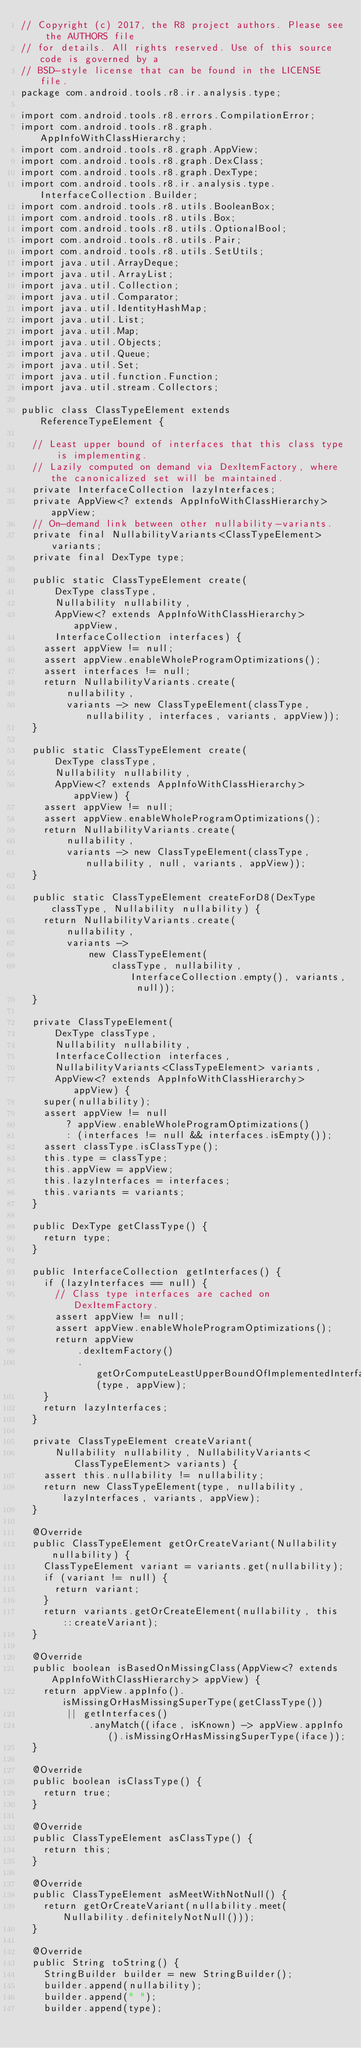<code> <loc_0><loc_0><loc_500><loc_500><_Java_>// Copyright (c) 2017, the R8 project authors. Please see the AUTHORS file
// for details. All rights reserved. Use of this source code is governed by a
// BSD-style license that can be found in the LICENSE file.
package com.android.tools.r8.ir.analysis.type;

import com.android.tools.r8.errors.CompilationError;
import com.android.tools.r8.graph.AppInfoWithClassHierarchy;
import com.android.tools.r8.graph.AppView;
import com.android.tools.r8.graph.DexClass;
import com.android.tools.r8.graph.DexType;
import com.android.tools.r8.ir.analysis.type.InterfaceCollection.Builder;
import com.android.tools.r8.utils.BooleanBox;
import com.android.tools.r8.utils.Box;
import com.android.tools.r8.utils.OptionalBool;
import com.android.tools.r8.utils.Pair;
import com.android.tools.r8.utils.SetUtils;
import java.util.ArrayDeque;
import java.util.ArrayList;
import java.util.Collection;
import java.util.Comparator;
import java.util.IdentityHashMap;
import java.util.List;
import java.util.Map;
import java.util.Objects;
import java.util.Queue;
import java.util.Set;
import java.util.function.Function;
import java.util.stream.Collectors;

public class ClassTypeElement extends ReferenceTypeElement {

  // Least upper bound of interfaces that this class type is implementing.
  // Lazily computed on demand via DexItemFactory, where the canonicalized set will be maintained.
  private InterfaceCollection lazyInterfaces;
  private AppView<? extends AppInfoWithClassHierarchy> appView;
  // On-demand link between other nullability-variants.
  private final NullabilityVariants<ClassTypeElement> variants;
  private final DexType type;

  public static ClassTypeElement create(
      DexType classType,
      Nullability nullability,
      AppView<? extends AppInfoWithClassHierarchy> appView,
      InterfaceCollection interfaces) {
    assert appView != null;
    assert appView.enableWholeProgramOptimizations();
    assert interfaces != null;
    return NullabilityVariants.create(
        nullability,
        variants -> new ClassTypeElement(classType, nullability, interfaces, variants, appView));
  }

  public static ClassTypeElement create(
      DexType classType,
      Nullability nullability,
      AppView<? extends AppInfoWithClassHierarchy> appView) {
    assert appView != null;
    assert appView.enableWholeProgramOptimizations();
    return NullabilityVariants.create(
        nullability,
        variants -> new ClassTypeElement(classType, nullability, null, variants, appView));
  }

  public static ClassTypeElement createForD8(DexType classType, Nullability nullability) {
    return NullabilityVariants.create(
        nullability,
        variants ->
            new ClassTypeElement(
                classType, nullability, InterfaceCollection.empty(), variants, null));
  }

  private ClassTypeElement(
      DexType classType,
      Nullability nullability,
      InterfaceCollection interfaces,
      NullabilityVariants<ClassTypeElement> variants,
      AppView<? extends AppInfoWithClassHierarchy> appView) {
    super(nullability);
    assert appView != null
        ? appView.enableWholeProgramOptimizations()
        : (interfaces != null && interfaces.isEmpty());
    assert classType.isClassType();
    this.type = classType;
    this.appView = appView;
    this.lazyInterfaces = interfaces;
    this.variants = variants;
  }

  public DexType getClassType() {
    return type;
  }

  public InterfaceCollection getInterfaces() {
    if (lazyInterfaces == null) {
      // Class type interfaces are cached on DexItemFactory.
      assert appView != null;
      assert appView.enableWholeProgramOptimizations();
      return appView
          .dexItemFactory()
          .getOrComputeLeastUpperBoundOfImplementedInterfaces(type, appView);
    }
    return lazyInterfaces;
  }

  private ClassTypeElement createVariant(
      Nullability nullability, NullabilityVariants<ClassTypeElement> variants) {
    assert this.nullability != nullability;
    return new ClassTypeElement(type, nullability, lazyInterfaces, variants, appView);
  }

  @Override
  public ClassTypeElement getOrCreateVariant(Nullability nullability) {
    ClassTypeElement variant = variants.get(nullability);
    if (variant != null) {
      return variant;
    }
    return variants.getOrCreateElement(nullability, this::createVariant);
  }

  @Override
  public boolean isBasedOnMissingClass(AppView<? extends AppInfoWithClassHierarchy> appView) {
    return appView.appInfo().isMissingOrHasMissingSuperType(getClassType())
        || getInterfaces()
            .anyMatch((iface, isKnown) -> appView.appInfo().isMissingOrHasMissingSuperType(iface));
  }

  @Override
  public boolean isClassType() {
    return true;
  }

  @Override
  public ClassTypeElement asClassType() {
    return this;
  }

  @Override
  public ClassTypeElement asMeetWithNotNull() {
    return getOrCreateVariant(nullability.meet(Nullability.definitelyNotNull()));
  }

  @Override
  public String toString() {
    StringBuilder builder = new StringBuilder();
    builder.append(nullability);
    builder.append(" ");
    builder.append(type);</code> 